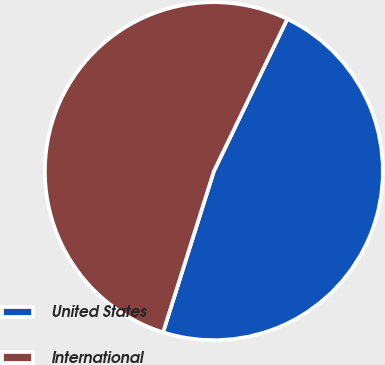Convert chart to OTSL. <chart><loc_0><loc_0><loc_500><loc_500><pie_chart><fcel>United States<fcel>International<nl><fcel>47.71%<fcel>52.29%<nl></chart> 